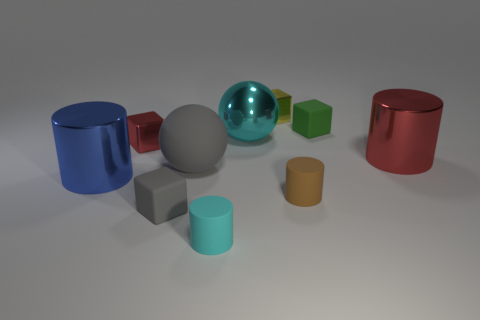There is a small matte object that is on the left side of the big rubber ball; what shape is it?
Make the answer very short. Cube. Is there a gray block that is behind the small matte thing behind the red metallic object that is left of the tiny green cube?
Your response must be concise. No. There is a big blue object that is the same shape as the cyan matte thing; what material is it?
Offer a terse response. Metal. Are there any other things that have the same material as the blue cylinder?
Your answer should be very brief. Yes. What number of balls are tiny gray matte objects or tiny shiny objects?
Ensure brevity in your answer.  0. Does the metallic thing that is behind the green block have the same size as the matte cube that is in front of the red shiny cylinder?
Give a very brief answer. Yes. The big cylinder to the left of the red metallic object on the right side of the small yellow object is made of what material?
Offer a terse response. Metal. Is the number of large gray rubber things behind the big rubber sphere less than the number of yellow things?
Provide a succinct answer. Yes. There is a red thing that is the same material as the large red cylinder; what shape is it?
Provide a succinct answer. Cube. How many other things are there of the same shape as the tiny cyan object?
Keep it short and to the point. 3. 